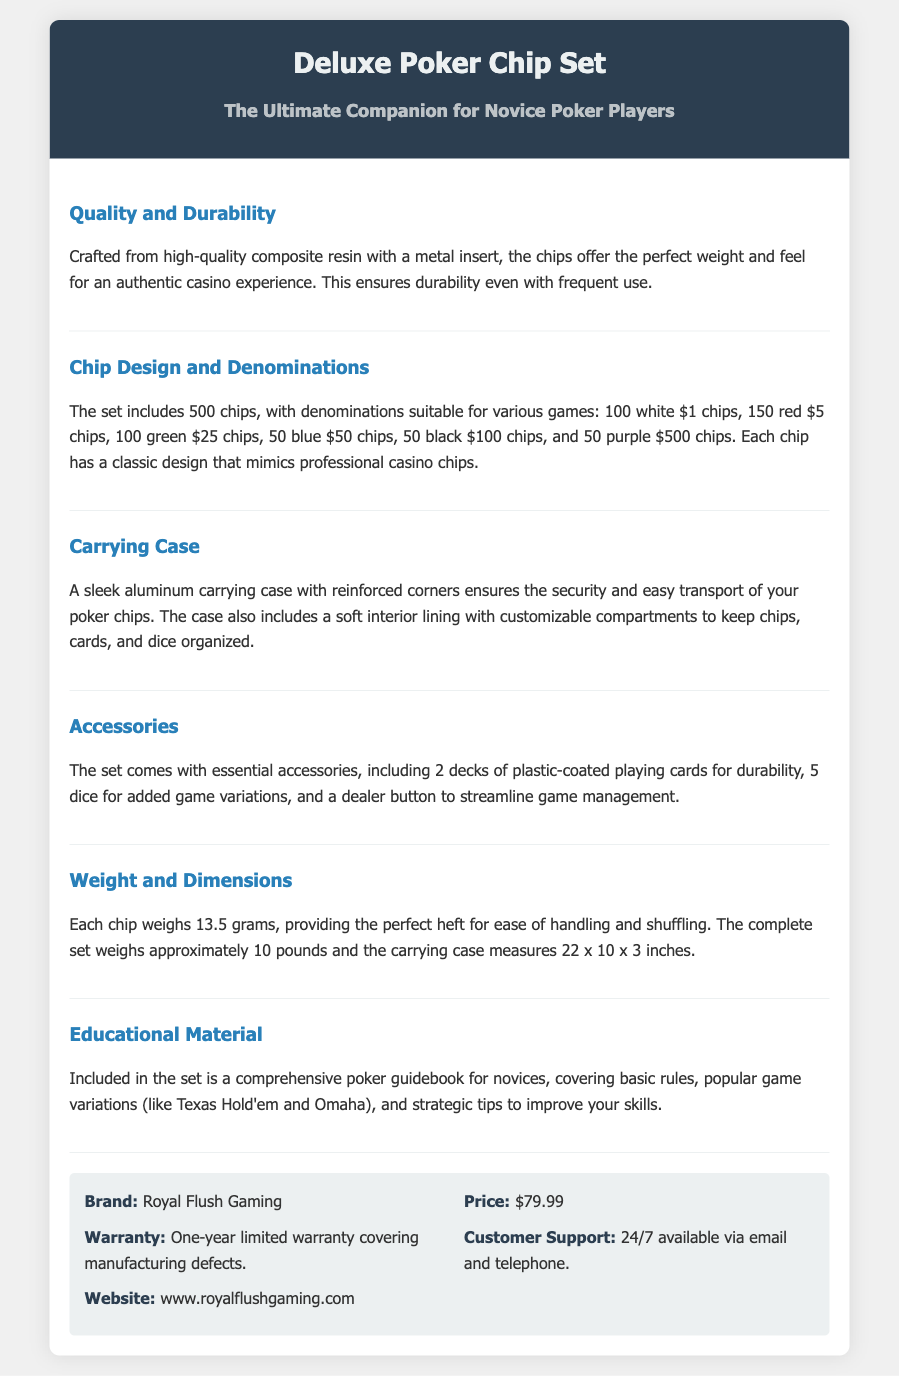what is the brand of the poker chip set? The document specifies that the brand of the poker chip set is Royal Flush Gaming.
Answer: Royal Flush Gaming how many chips are included in the set? The document states that the set includes a total of 500 chips.
Answer: 500 chips what is the weight of each chip? Each chip weighs 13.5 grams, as mentioned in the specifications.
Answer: 13.5 grams what accessories are included in the set? The document lists accessories, including 2 decks of plastic-coated playing cards, 5 dice, and a dealer button.
Answer: 2 decks of plastic-coated playing cards, 5 dice, and a dealer button what type of carrying case does the set come with? The document describes the carrying case as a sleek aluminum carrying case with reinforced corners.
Answer: Aluminum carrying case what is the price of the poker chip set? The price of the poker chip set is directly stated in the document as $79.99.
Answer: $79.99 how does the poker chip set support novice players? The document includes a comprehensive poker guidebook that covers basic rules and strategies for improving skills.
Answer: Poker guidebook what is the warranty period for the product? The document mentions a one-year limited warranty covering manufacturing defects.
Answer: One-year limited warranty 